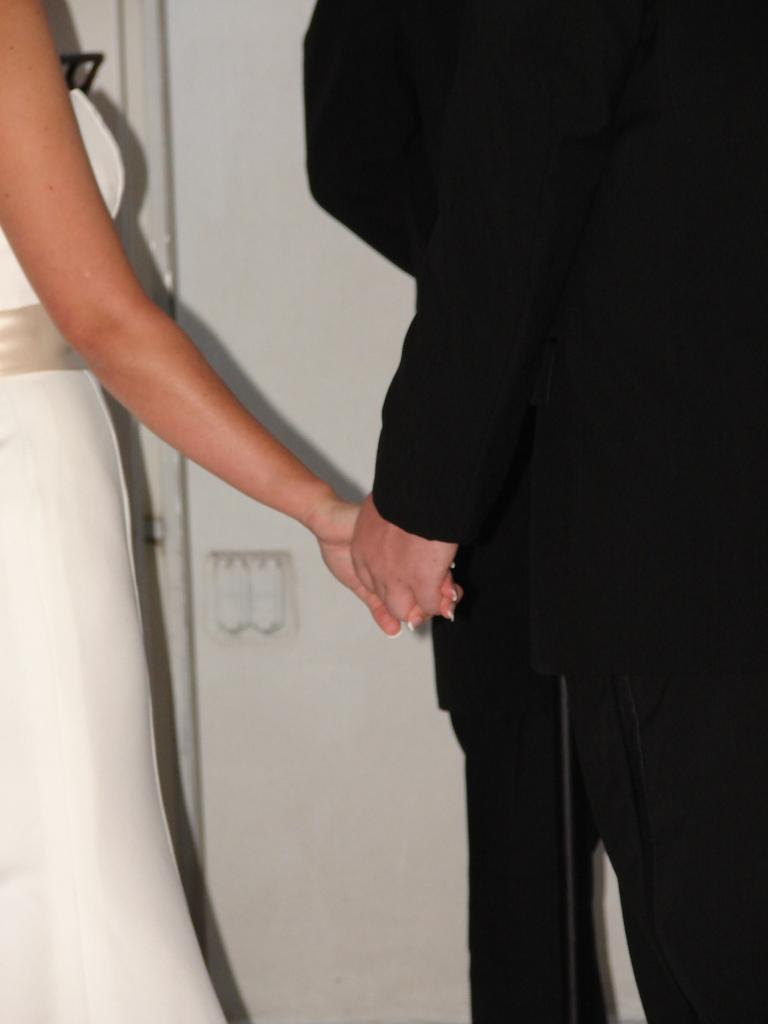Who is present in the image? There is a man and a woman in the image. What are the man and woman doing in the image? The man and woman are holding hands in the image. What is the woman wearing in the image? The woman is wearing a white dress in the image. What type of trains can be seen in the image? There are no trains present in the image; it features a man and a woman holding hands. What class is the woman attending in the image? There is no class or educational setting depicted in the image. 